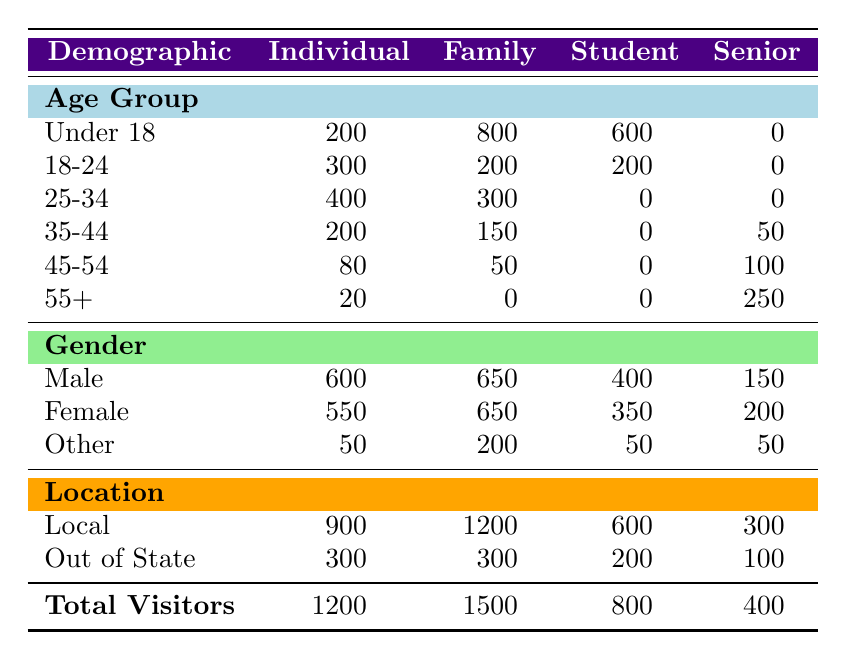What is the total number of visitors for Family membership type? The table shows a specific row for Family, and the Total Visitors value is listed. According to the table, Family has 1500 total visitors.
Answer: 1500 How many visitors are Male under the Individual membership type? Looking at the Individual section, under the Gender category, the number of Male visitors is provided directly in the table. It states there are 600 Male visitors under Individual.
Answer: 600 What is the age group with the highest number of visitors for the Student membership type? For Student membership, it is necessary to compare the values listed under the Age Group section. The highest value is for Under 18, with 600 visitors, the next highest is 200 for 18-24, while the others are 0. Therefore, Under 18 has the highest visitors.
Answer: Under 18 Are there more Female visitors than Male visitors in the Senior membership category? The table shows 200 Female visitors and 150 Male visitors under the Senior category. Comparing these two numbers, it's clear that Female visitors are more than Male visitors.
Answer: Yes What is the total number of Local visitors across all membership types? To find this value, we will need to sum the Local visitors for each membership type: Individual (900) + Family (1200) + Student (600) + Senior (300) = 3000. Therefore, the total number of Local visitors is 3000.
Answer: 3000 Which membership type has the lowest total number of visitors? By looking at the Total Visitors row at the bottom and comparing the values for each membership type, we find that Senior has the lowest total at 400.
Answer: Senior What percentage of the total visitors from the Family membership type are Male? The total visitors for Family is 1500, and the number of Male visitors is 650. To find the percentage, we calculate (650 / 1500) * 100 = 43.33. Thus, the percentage of Male visitors is approximately 43.33%.
Answer: 43.33% How many visitors are in the age group of 35-44 among the Senior membership type? Referring to the specific section for Senior and the Age Group subsection, we see that the number of visitors in the age group of 35-44 is 50. Thus, there are 50 visitors in that age group for Seniors.
Answer: 50 If we combine the number of visitors in the 45-54 age group across Individual and Senior membership types, what is the sum? Individually, the 45-54 age group has 80 visitors under Individual and 100 under Senior. Adding these together, we get 80 + 100 = 180. Thus, the sum for the age group of 45-54 across both types is 180.
Answer: 180 